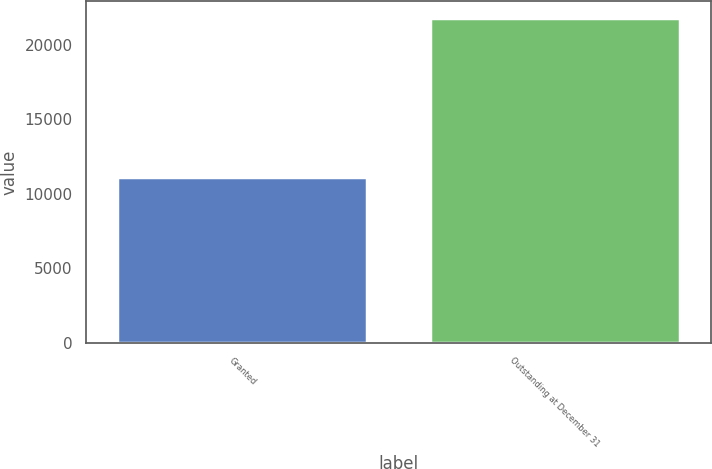Convert chart to OTSL. <chart><loc_0><loc_0><loc_500><loc_500><bar_chart><fcel>Granted<fcel>Outstanding at December 31<nl><fcel>11130<fcel>21835<nl></chart> 